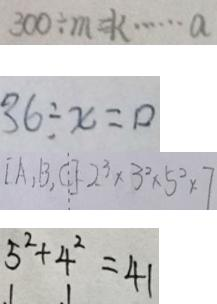Convert formula to latex. <formula><loc_0><loc_0><loc_500><loc_500>3 0 0 \div m = k \cdots a 
 3 6 \div x = 0 
 [ A , B , C ] = 2 ^ { 3 } \times 3 ^ { 2 } \times 5 ^ { 2 } \times 7 
 5 ^ { 2 } + 4 ^ { 2 } = 4 1</formula> 